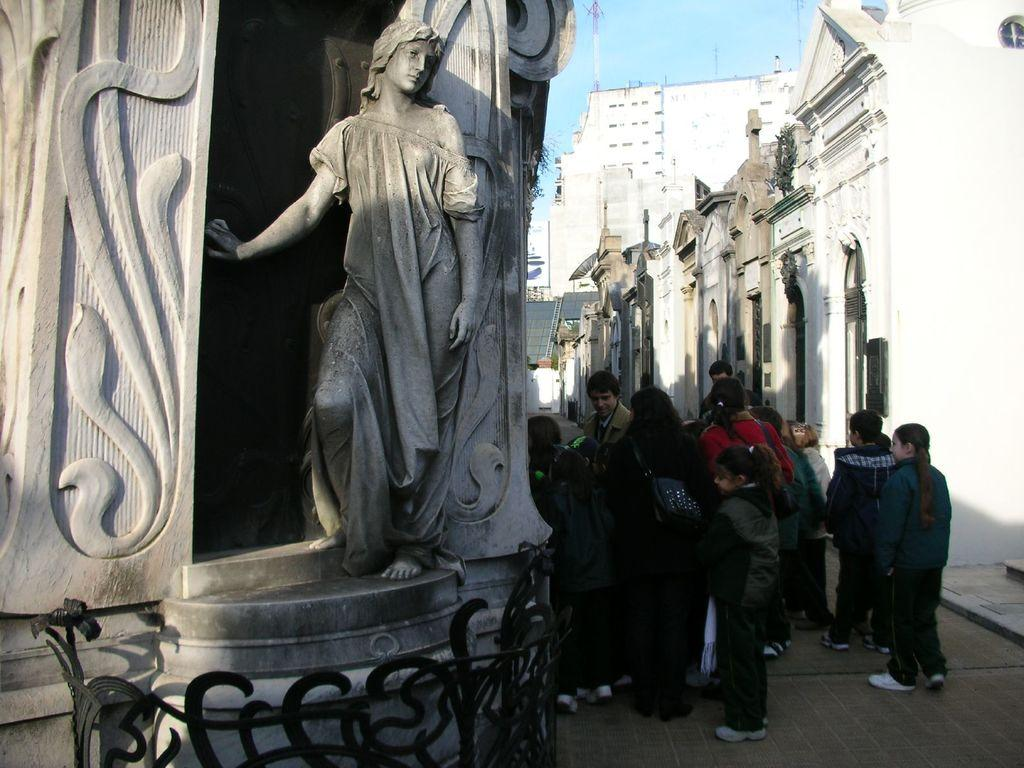What type of structures can be seen in the image? There are buildings in the image. What is the statue in the image depicting? The statue in the image is not specified, but it is present. Can you describe the people in the image? There are people standing in the image. How would you describe the sky in the image? The sky is blue and cloudy in the image. What type of muscle is being exercised by the farmer in the image? There is no farmer or muscle-related activity present in the image. 